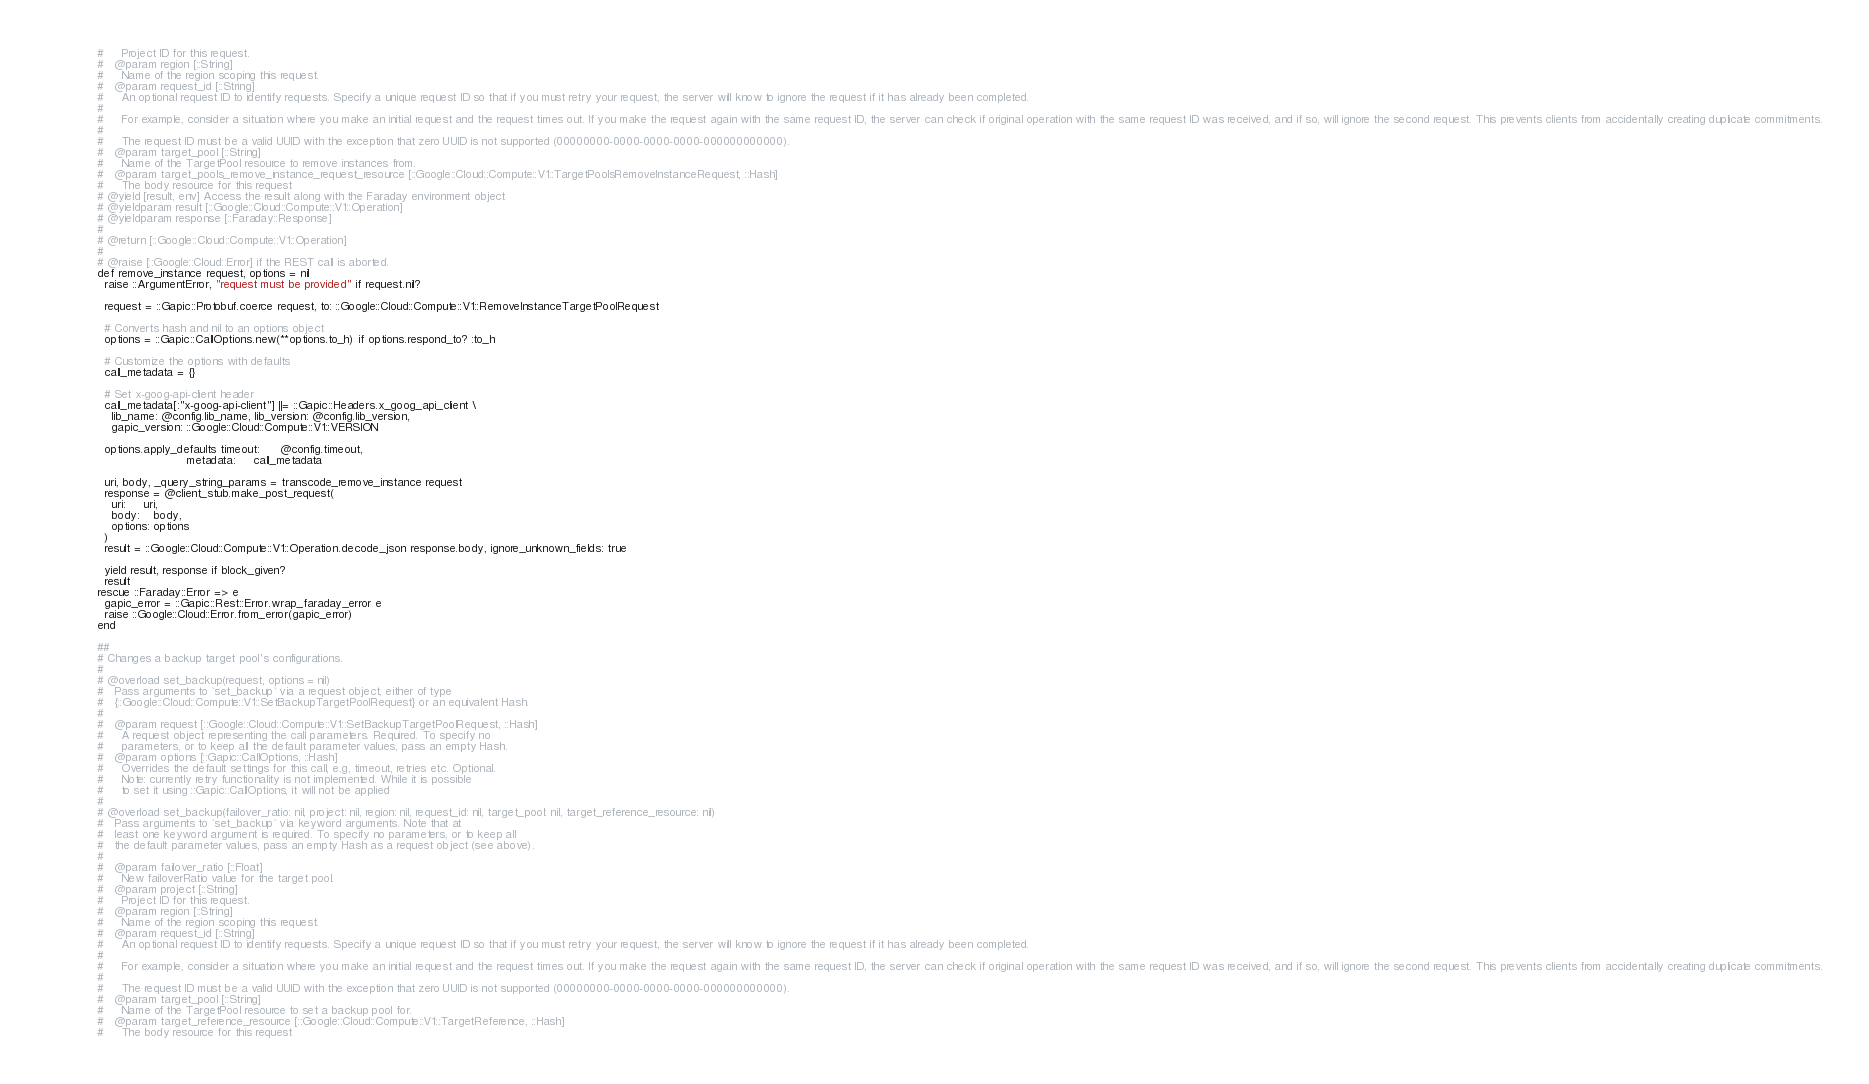Convert code to text. <code><loc_0><loc_0><loc_500><loc_500><_Ruby_>              #     Project ID for this request.
              #   @param region [::String]
              #     Name of the region scoping this request.
              #   @param request_id [::String]
              #     An optional request ID to identify requests. Specify a unique request ID so that if you must retry your request, the server will know to ignore the request if it has already been completed.
              #
              #     For example, consider a situation where you make an initial request and the request times out. If you make the request again with the same request ID, the server can check if original operation with the same request ID was received, and if so, will ignore the second request. This prevents clients from accidentally creating duplicate commitments.
              #
              #     The request ID must be a valid UUID with the exception that zero UUID is not supported (00000000-0000-0000-0000-000000000000).
              #   @param target_pool [::String]
              #     Name of the TargetPool resource to remove instances from.
              #   @param target_pools_remove_instance_request_resource [::Google::Cloud::Compute::V1::TargetPoolsRemoveInstanceRequest, ::Hash]
              #     The body resource for this request
              # @yield [result, env] Access the result along with the Faraday environment object
              # @yieldparam result [::Google::Cloud::Compute::V1::Operation]
              # @yieldparam response [::Faraday::Response]
              #
              # @return [::Google::Cloud::Compute::V1::Operation]
              #
              # @raise [::Google::Cloud::Error] if the REST call is aborted.
              def remove_instance request, options = nil
                raise ::ArgumentError, "request must be provided" if request.nil?

                request = ::Gapic::Protobuf.coerce request, to: ::Google::Cloud::Compute::V1::RemoveInstanceTargetPoolRequest

                # Converts hash and nil to an options object
                options = ::Gapic::CallOptions.new(**options.to_h) if options.respond_to? :to_h

                # Customize the options with defaults
                call_metadata = {}

                # Set x-goog-api-client header
                call_metadata[:"x-goog-api-client"] ||= ::Gapic::Headers.x_goog_api_client \
                  lib_name: @config.lib_name, lib_version: @config.lib_version,
                  gapic_version: ::Google::Cloud::Compute::V1::VERSION

                options.apply_defaults timeout:      @config.timeout,
                                       metadata:     call_metadata

                uri, body, _query_string_params = transcode_remove_instance request
                response = @client_stub.make_post_request(
                  uri:     uri,
                  body:    body,
                  options: options
                )
                result = ::Google::Cloud::Compute::V1::Operation.decode_json response.body, ignore_unknown_fields: true

                yield result, response if block_given?
                result
              rescue ::Faraday::Error => e
                gapic_error = ::Gapic::Rest::Error.wrap_faraday_error e
                raise ::Google::Cloud::Error.from_error(gapic_error)
              end

              ##
              # Changes a backup target pool's configurations.
              #
              # @overload set_backup(request, options = nil)
              #   Pass arguments to `set_backup` via a request object, either of type
              #   {::Google::Cloud::Compute::V1::SetBackupTargetPoolRequest} or an equivalent Hash.
              #
              #   @param request [::Google::Cloud::Compute::V1::SetBackupTargetPoolRequest, ::Hash]
              #     A request object representing the call parameters. Required. To specify no
              #     parameters, or to keep all the default parameter values, pass an empty Hash.
              #   @param options [::Gapic::CallOptions, ::Hash]
              #     Overrides the default settings for this call, e.g, timeout, retries etc. Optional.
              #     Note: currently retry functionality is not implemented. While it is possible
              #     to set it using ::Gapic::CallOptions, it will not be applied
              #
              # @overload set_backup(failover_ratio: nil, project: nil, region: nil, request_id: nil, target_pool: nil, target_reference_resource: nil)
              #   Pass arguments to `set_backup` via keyword arguments. Note that at
              #   least one keyword argument is required. To specify no parameters, or to keep all
              #   the default parameter values, pass an empty Hash as a request object (see above).
              #
              #   @param failover_ratio [::Float]
              #     New failoverRatio value for the target pool.
              #   @param project [::String]
              #     Project ID for this request.
              #   @param region [::String]
              #     Name of the region scoping this request.
              #   @param request_id [::String]
              #     An optional request ID to identify requests. Specify a unique request ID so that if you must retry your request, the server will know to ignore the request if it has already been completed.
              #
              #     For example, consider a situation where you make an initial request and the request times out. If you make the request again with the same request ID, the server can check if original operation with the same request ID was received, and if so, will ignore the second request. This prevents clients from accidentally creating duplicate commitments.
              #
              #     The request ID must be a valid UUID with the exception that zero UUID is not supported (00000000-0000-0000-0000-000000000000).
              #   @param target_pool [::String]
              #     Name of the TargetPool resource to set a backup pool for.
              #   @param target_reference_resource [::Google::Cloud::Compute::V1::TargetReference, ::Hash]
              #     The body resource for this request</code> 